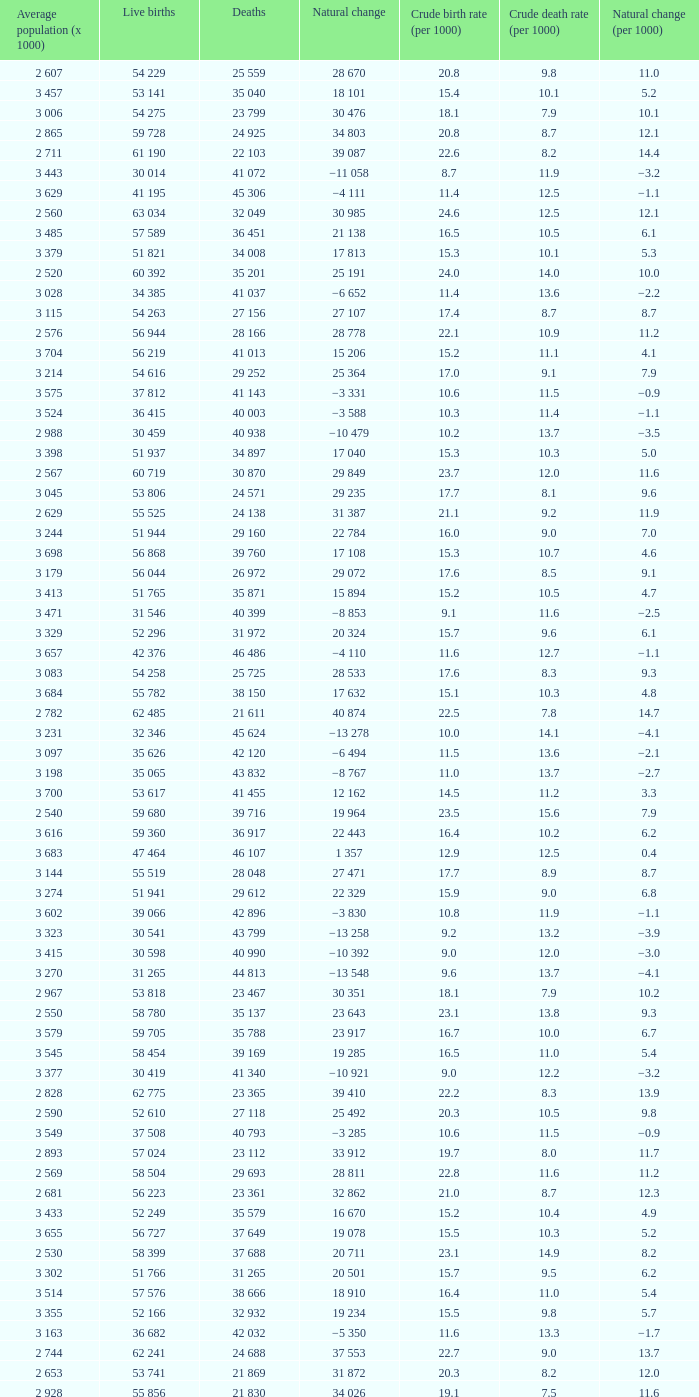Which Average population (x 1000) has a Crude death rate (per 1000) smaller than 10.9, and a Crude birth rate (per 1000) smaller than 19.7, and a Natural change (per 1000) of 8.7, and Live births of 54 263? 3 115. 